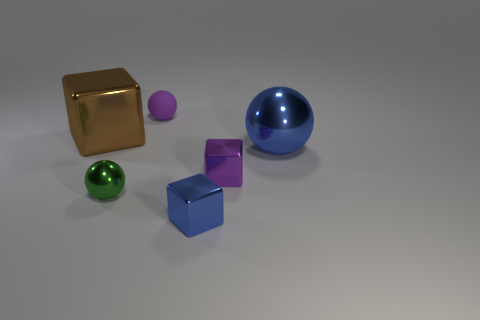Add 1 tiny gray shiny things. How many objects exist? 7 Subtract all small purple shiny cubes. Subtract all blue metal spheres. How many objects are left? 4 Add 4 small spheres. How many small spheres are left? 6 Add 5 green metal spheres. How many green metal spheres exist? 6 Subtract 0 cyan cylinders. How many objects are left? 6 